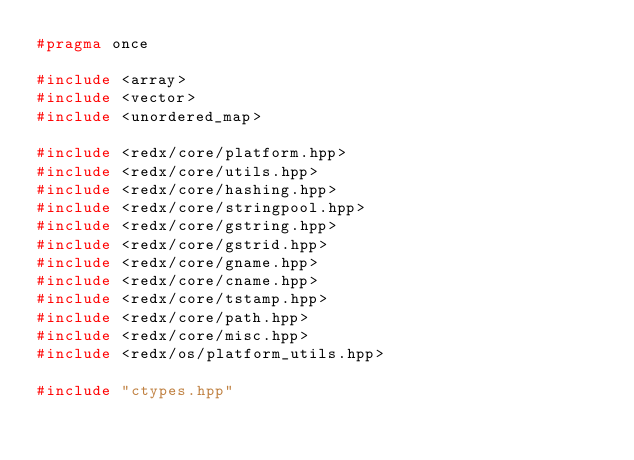Convert code to text. <code><loc_0><loc_0><loc_500><loc_500><_C++_>#pragma once

#include <array>
#include <vector>
#include <unordered_map>

#include <redx/core/platform.hpp>
#include <redx/core/utils.hpp>
#include <redx/core/hashing.hpp>
#include <redx/core/stringpool.hpp>
#include <redx/core/gstring.hpp>
#include <redx/core/gstrid.hpp>
#include <redx/core/gname.hpp>
#include <redx/core/cname.hpp>
#include <redx/core/tstamp.hpp>
#include <redx/core/path.hpp>
#include <redx/core/misc.hpp>
#include <redx/os/platform_utils.hpp>

#include "ctypes.hpp"

</code> 